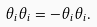<formula> <loc_0><loc_0><loc_500><loc_500>\theta _ { i } \theta _ { i } = - \theta _ { i } \theta _ { i } .</formula> 